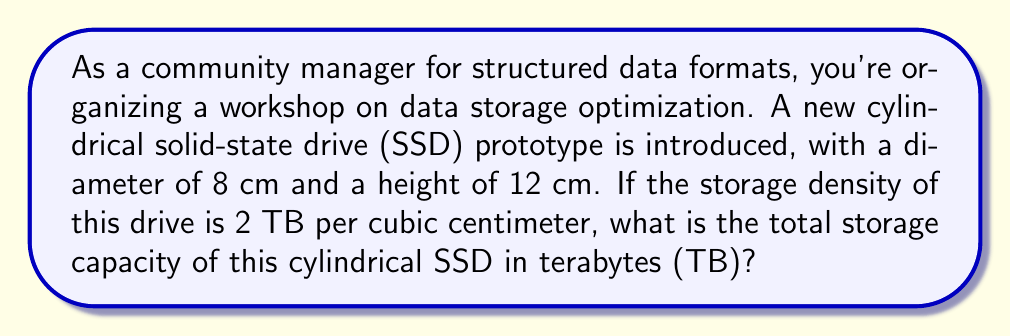Could you help me with this problem? To solve this problem, we need to follow these steps:

1. Calculate the volume of the cylindrical SSD
2. Multiply the volume by the storage density to get the total storage capacity

Step 1: Calculate the volume of the cylindrical SSD

The volume of a cylinder is given by the formula:

$$V = \pi r^2 h$$

Where:
$r$ is the radius of the base
$h$ is the height of the cylinder

We're given the diameter (8 cm), so we need to halve it to get the radius:

$r = 8 \text{ cm} \div 2 = 4 \text{ cm}$

Now we can plug the values into the formula:

$$\begin{align*}
V &= \pi (4 \text{ cm})^2 (12 \text{ cm}) \\
&= \pi (16 \text{ cm}^2) (12 \text{ cm}) \\
&= 192\pi \text{ cm}^3 \\
&\approx 603.19 \text{ cm}^3
\end{align*}$$

Step 2: Calculate the total storage capacity

The storage density is 2 TB per cubic centimeter, so we multiply the volume by this density:

$$\begin{align*}
\text{Storage Capacity} &= 603.19 \text{ cm}^3 \times 2 \text{ TB/cm}^3 \\
&= 1,206.38 \text{ TB}
\end{align*}$$

Therefore, the total storage capacity of the cylindrical SSD is approximately 1,206.38 TB.

[asy]
import geometry;

size(200);

real r = 4;
real h = 12;

path base = circle((0,0), r);
path top = circle((0,h), r);

draw(base);
draw(top);
draw((r,0)--(r,h));
draw((-r,0)--(-r,h));

label("8 cm", (0,-r-0.5), S);
label("12 cm", (r+0.5,h/2), E);

[/asy]
Answer: The total storage capacity of the cylindrical SSD is approximately 1,206.38 TB. 